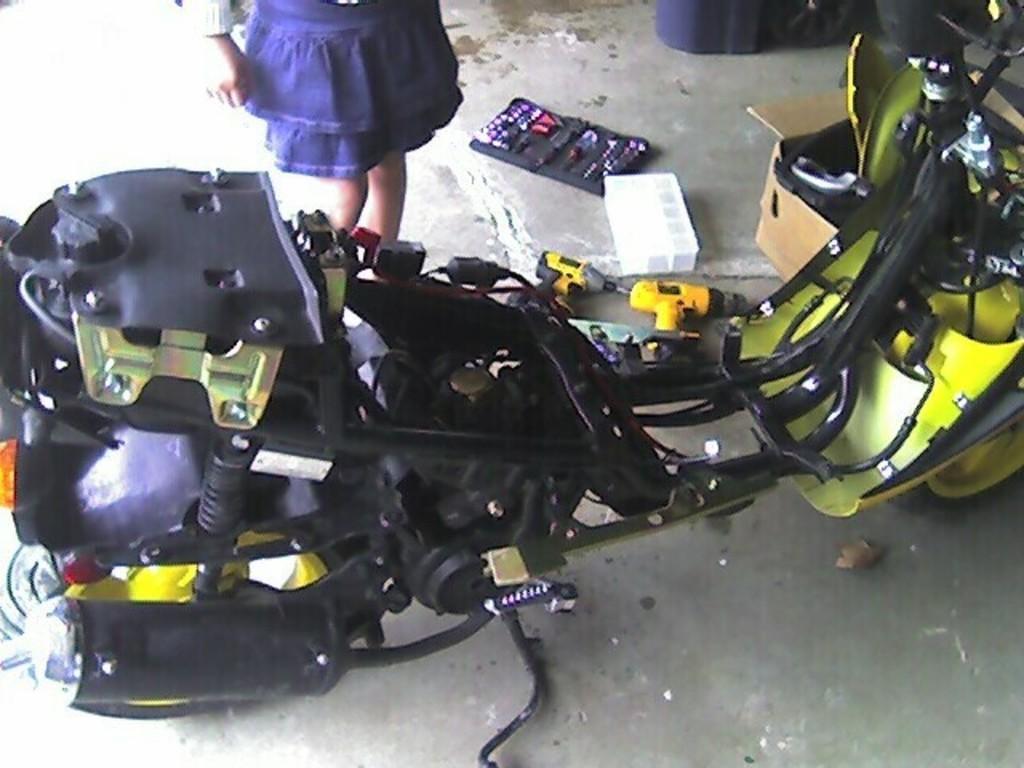In one or two sentences, can you explain what this image depicts? In this picture we can see a motorcycle on the ground and in the background we can see a person, box, device and some objects. 